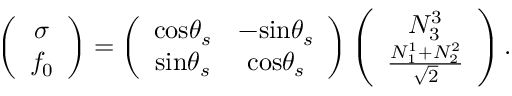<formula> <loc_0><loc_0><loc_500><loc_500>\left ( \begin{array} { c } { \sigma } \\ { { f _ { 0 } } } \end{array} \right ) = \left ( \begin{array} { c c } { { \cos \theta _ { s } } } & { { - \sin \theta _ { s } } } \\ { { \sin \theta _ { s } } } & { { \cos \theta _ { s } } } \end{array} \right ) \left ( \begin{array} { c } { { N _ { 3 } ^ { 3 } } } \\ { { \frac { N _ { 1 } ^ { 1 } + N _ { 2 } ^ { 2 } } { \sqrt { 2 } } } } \end{array} \right ) .</formula> 